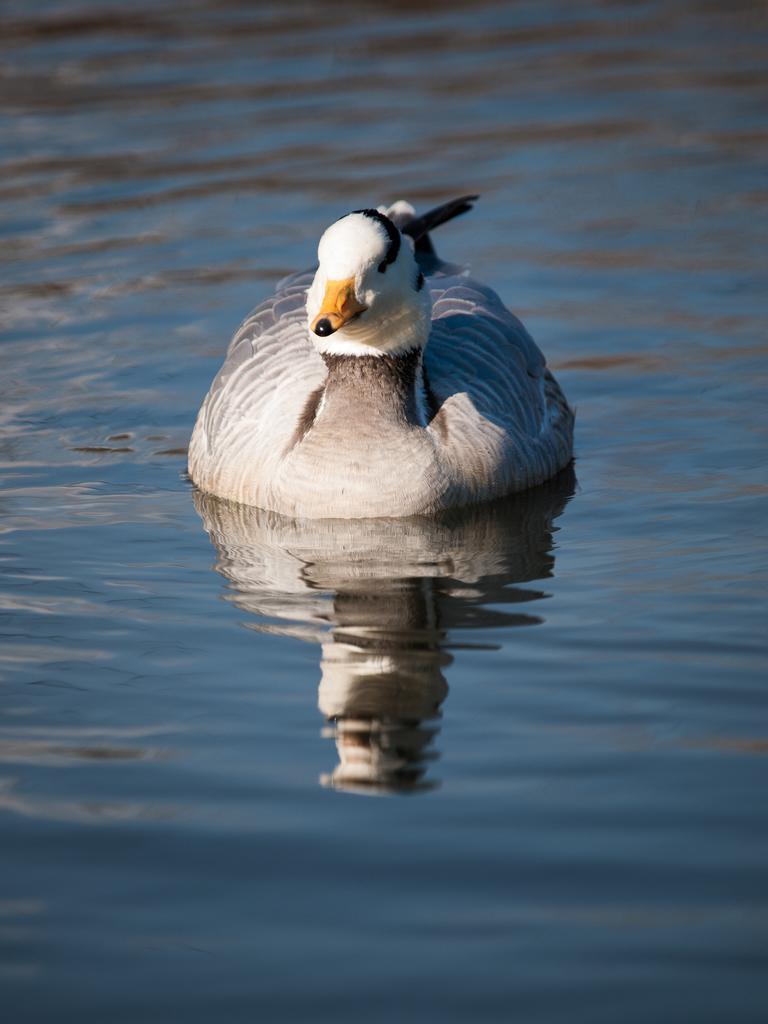How would you summarize this image in a sentence or two? In the image there is a duck swimming on the water, it has a yellow beak. 